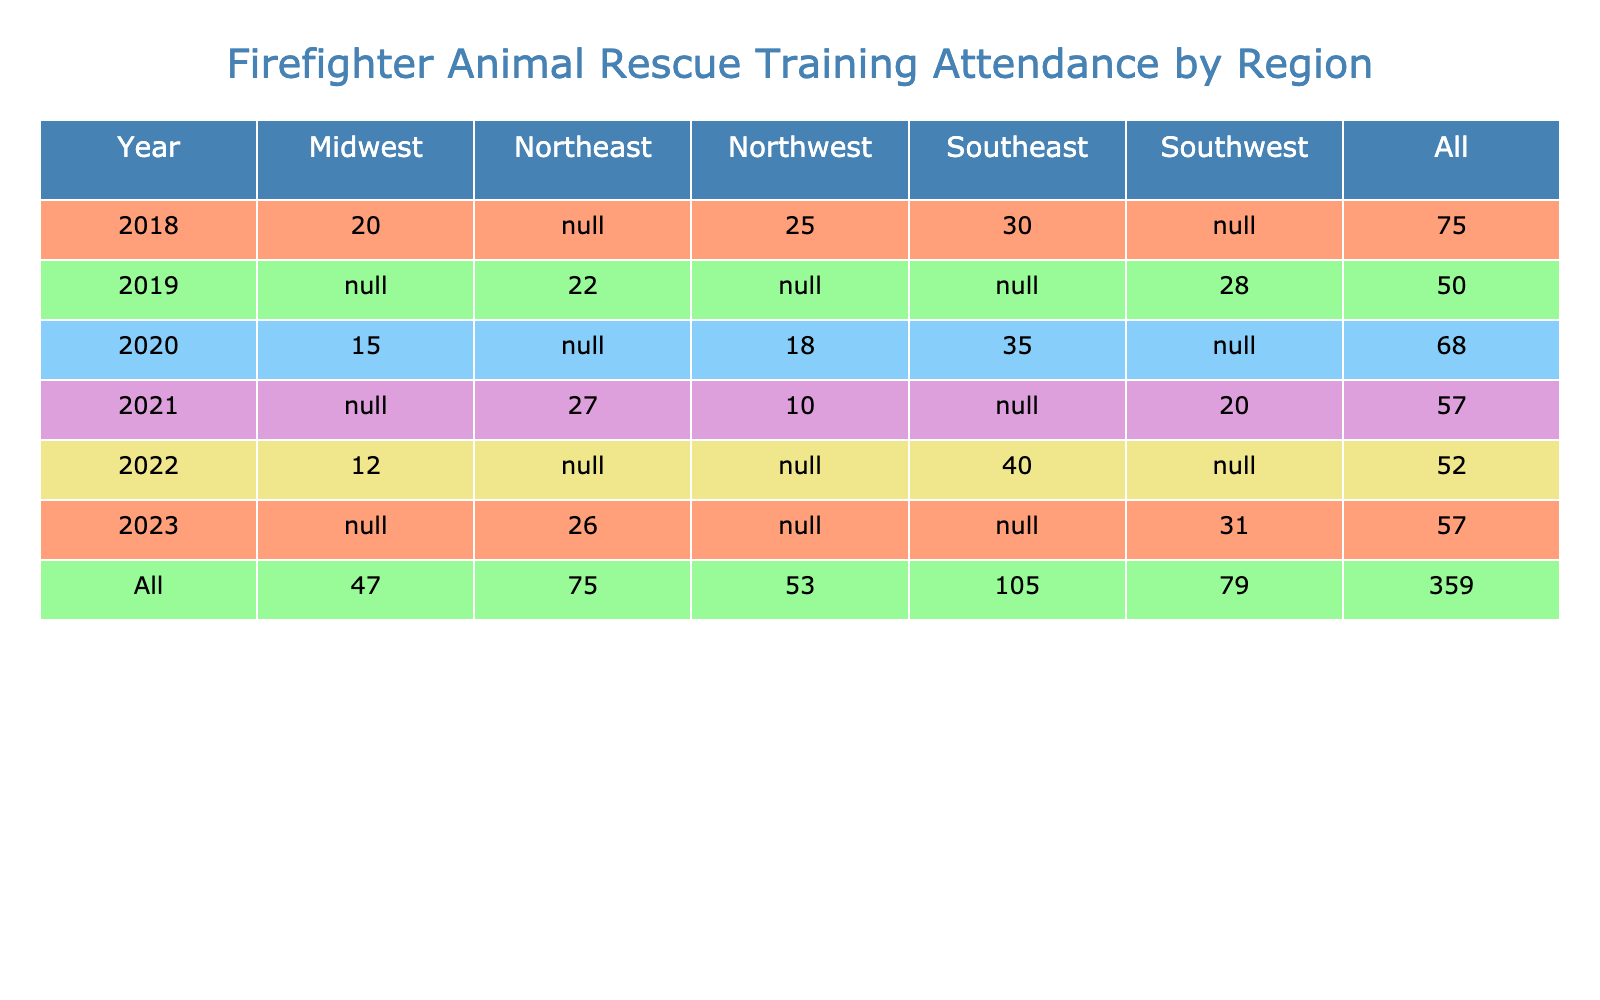What was the total number of attendees for training sessions in the Southeast region in 2020? In 2020, there are two entries for the Southeast region: Domestic Animal Handling with 35 attendees and no other training sessions listed. Therefore, the total for the Southeast in 2020 is simply 35.
Answer: 35 Which year had the highest number of attendees in the Midwest region? The Midwest region's training sessions across the years show: 20 in 2018, 15 in 2020, and 12 in 2022. The highest number is 20 in 2018.
Answer: 2018 Did any training sessions in the Northeast region have fewer than 25 attendees? The training sessions in the Northeast show 22 for Advanced Animal Rescue Techniques in 2019 and 26 for Critical Care for Wildlife in 2023. Therefore, the answer is yes, as there was one session (22 attendees) with fewer than 25.
Answer: Yes What is the average number of attendees for training sessions focused on large mammals across all regions? The only relevant entry for large mammals is Large Mammal Rescue Techniques in 2022 with 12 attendees. Hence, since there is only one data point, the average is simply the same: 12.
Answer: 12 How many total attendees participated in animal rescue trainings in the Northwest across all years? In the Northwest region, the attendees are: 25 (2018) + 18 (2020) + 10 (2021) = 53 total attendees.
Answer: 53 Which region showed the highest attendance for animal rescue trainings in 2022? In 2022, the Southeast region attended 40 sessions, whereas the Midwest had only 12. The Southeast has the highest attendance that year.
Answer: Southeast In which year did the Southwest region have the most training attendees? The Southwest's numbers are: 28 attendees in 2019 for Urban Animal Response, 20 in 2021 for Feline Rescue Strategies, and 31 in 2023 for Stray Animal Management. The maximum for the Southwest is 31 in 2023.
Answer: 2023 Was there any training session focused specifically on equine rescue techniques? The data shows one entry: Equine Rescue Techniques in 2020 specifically concerning equines. Therefore, the answer is yes, there was such a session.
Answer: Yes 